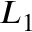Convert formula to latex. <formula><loc_0><loc_0><loc_500><loc_500>L _ { 1 }</formula> 